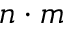Convert formula to latex. <formula><loc_0><loc_0><loc_500><loc_500>n \cdot m</formula> 